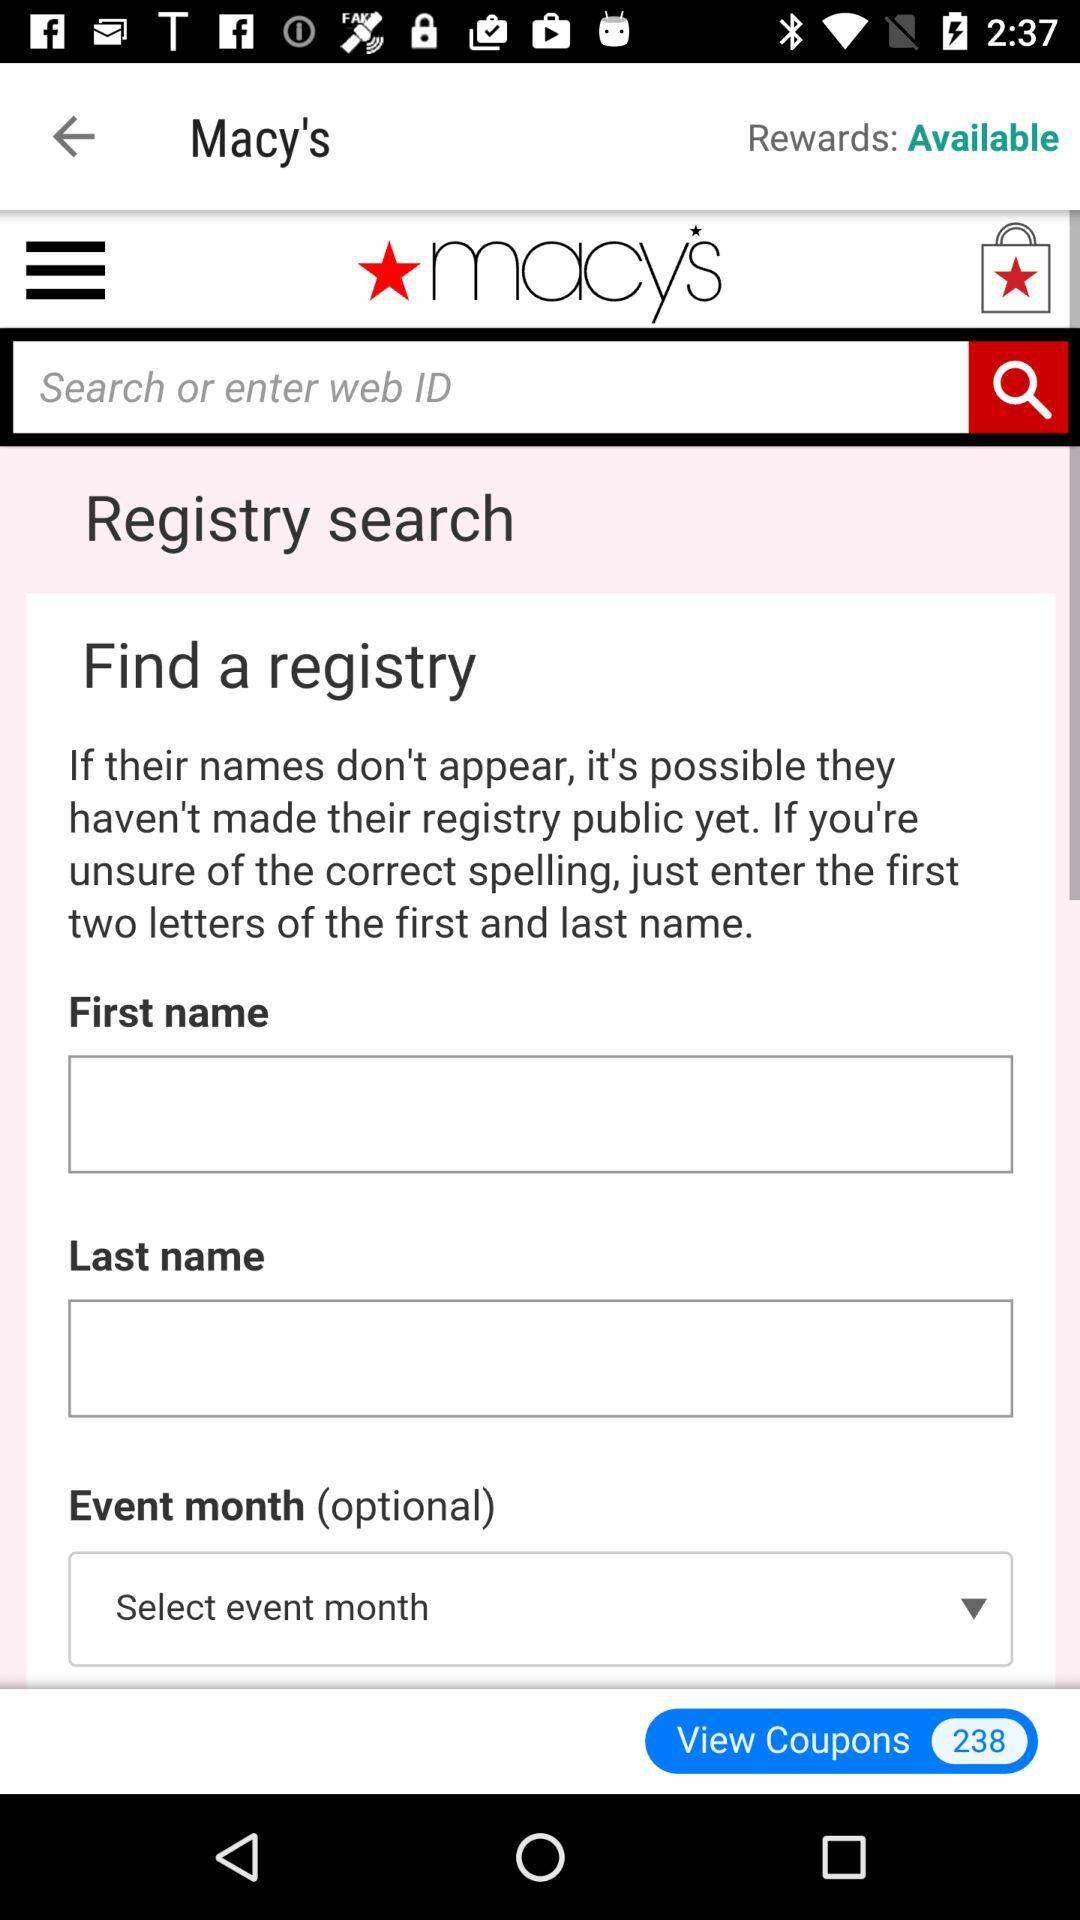What is the name of the application? The name of the application is "Macy's". 